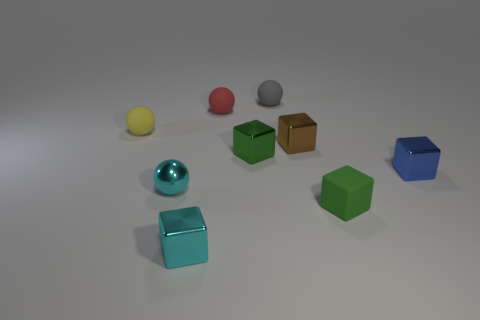There is a brown object that is the same shape as the blue metal thing; what material is it?
Offer a very short reply. Metal. What material is the green object that is in front of the tiny shiny block that is on the right side of the green cube to the right of the small gray matte thing?
Keep it short and to the point. Rubber. What size is the cube that is the same material as the small yellow thing?
Make the answer very short. Small. Are there any other things that have the same color as the rubber cube?
Your response must be concise. Yes. There is a tiny metallic cube in front of the blue metallic cube; is it the same color as the small rubber object that is to the left of the tiny shiny sphere?
Provide a succinct answer. No. What is the color of the metallic block on the right side of the small brown block?
Ensure brevity in your answer.  Blue. Is the size of the rubber object that is to the left of the cyan block the same as the small green matte cube?
Provide a succinct answer. Yes. Is the number of green cylinders less than the number of small rubber balls?
Offer a very short reply. Yes. The thing that is the same color as the tiny matte cube is what shape?
Provide a short and direct response. Cube. How many yellow matte spheres are to the right of the small blue metal thing?
Make the answer very short. 0. 